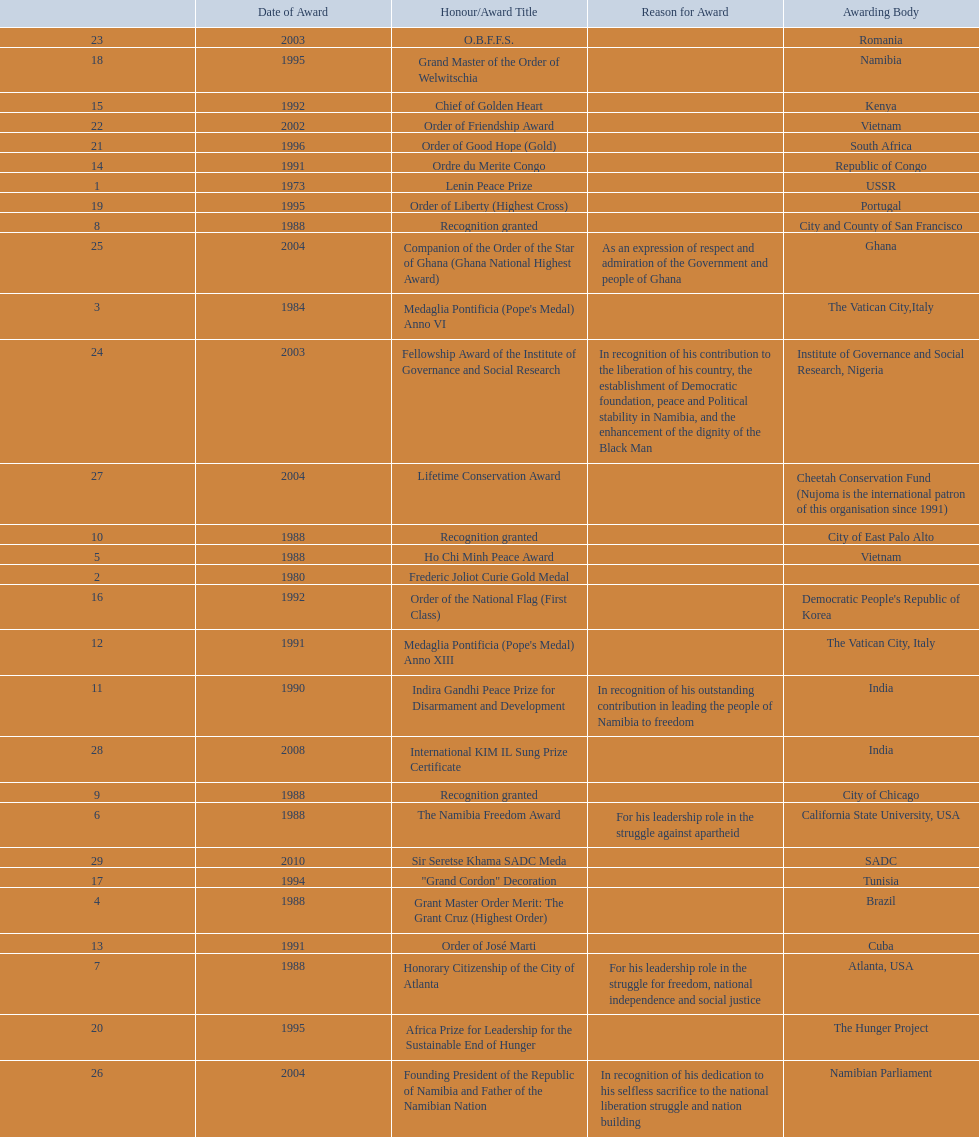Which awarding bodies have recognized sam nujoma? USSR, , The Vatican City,Italy, Brazil, Vietnam, California State University, USA, Atlanta, USA, City and County of San Francisco, City of Chicago, City of East Palo Alto, India, The Vatican City, Italy, Cuba, Republic of Congo, Kenya, Democratic People's Republic of Korea, Tunisia, Namibia, Portugal, The Hunger Project, South Africa, Vietnam, Romania, Institute of Governance and Social Research, Nigeria, Ghana, Namibian Parliament, Cheetah Conservation Fund (Nujoma is the international patron of this organisation since 1991), India, SADC. And what was the title of each award or honour? Lenin Peace Prize, Frederic Joliot Curie Gold Medal, Medaglia Pontificia (Pope's Medal) Anno VI, Grant Master Order Merit: The Grant Cruz (Highest Order), Ho Chi Minh Peace Award, The Namibia Freedom Award, Honorary Citizenship of the City of Atlanta, Recognition granted, Recognition granted, Recognition granted, Indira Gandhi Peace Prize for Disarmament and Development, Medaglia Pontificia (Pope's Medal) Anno XIII, Order of José Marti, Ordre du Merite Congo, Chief of Golden Heart, Order of the National Flag (First Class), "Grand Cordon" Decoration, Grand Master of the Order of Welwitschia, Order of Liberty (Highest Cross), Africa Prize for Leadership for the Sustainable End of Hunger, Order of Good Hope (Gold), Order of Friendship Award, O.B.F.F.S., Fellowship Award of the Institute of Governance and Social Research, Companion of the Order of the Star of Ghana (Ghana National Highest Award), Founding President of the Republic of Namibia and Father of the Namibian Nation, Lifetime Conservation Award, International KIM IL Sung Prize Certificate, Sir Seretse Khama SADC Meda. Of those, which nation awarded him the o.b.f.f.s.? Romania. 